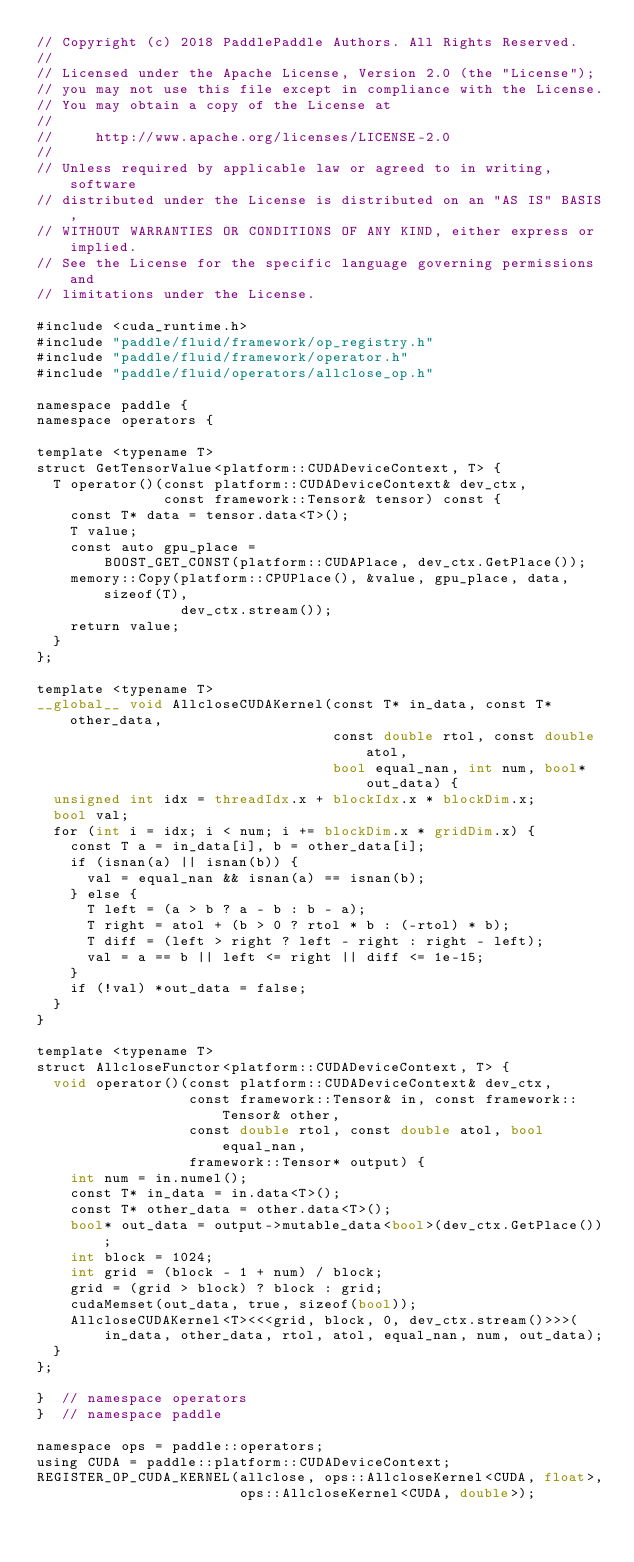Convert code to text. <code><loc_0><loc_0><loc_500><loc_500><_Cuda_>// Copyright (c) 2018 PaddlePaddle Authors. All Rights Reserved.
//
// Licensed under the Apache License, Version 2.0 (the "License");
// you may not use this file except in compliance with the License.
// You may obtain a copy of the License at
//
//     http://www.apache.org/licenses/LICENSE-2.0
//
// Unless required by applicable law or agreed to in writing, software
// distributed under the License is distributed on an "AS IS" BASIS,
// WITHOUT WARRANTIES OR CONDITIONS OF ANY KIND, either express or implied.
// See the License for the specific language governing permissions and
// limitations under the License.

#include <cuda_runtime.h>
#include "paddle/fluid/framework/op_registry.h"
#include "paddle/fluid/framework/operator.h"
#include "paddle/fluid/operators/allclose_op.h"

namespace paddle {
namespace operators {

template <typename T>
struct GetTensorValue<platform::CUDADeviceContext, T> {
  T operator()(const platform::CUDADeviceContext& dev_ctx,
               const framework::Tensor& tensor) const {
    const T* data = tensor.data<T>();
    T value;
    const auto gpu_place =
        BOOST_GET_CONST(platform::CUDAPlace, dev_ctx.GetPlace());
    memory::Copy(platform::CPUPlace(), &value, gpu_place, data, sizeof(T),
                 dev_ctx.stream());
    return value;
  }
};

template <typename T>
__global__ void AllcloseCUDAKernel(const T* in_data, const T* other_data,
                                   const double rtol, const double atol,
                                   bool equal_nan, int num, bool* out_data) {
  unsigned int idx = threadIdx.x + blockIdx.x * blockDim.x;
  bool val;
  for (int i = idx; i < num; i += blockDim.x * gridDim.x) {
    const T a = in_data[i], b = other_data[i];
    if (isnan(a) || isnan(b)) {
      val = equal_nan && isnan(a) == isnan(b);
    } else {
      T left = (a > b ? a - b : b - a);
      T right = atol + (b > 0 ? rtol * b : (-rtol) * b);
      T diff = (left > right ? left - right : right - left);
      val = a == b || left <= right || diff <= 1e-15;
    }
    if (!val) *out_data = false;
  }
}

template <typename T>
struct AllcloseFunctor<platform::CUDADeviceContext, T> {
  void operator()(const platform::CUDADeviceContext& dev_ctx,
                  const framework::Tensor& in, const framework::Tensor& other,
                  const double rtol, const double atol, bool equal_nan,
                  framework::Tensor* output) {
    int num = in.numel();
    const T* in_data = in.data<T>();
    const T* other_data = other.data<T>();
    bool* out_data = output->mutable_data<bool>(dev_ctx.GetPlace());
    int block = 1024;
    int grid = (block - 1 + num) / block;
    grid = (grid > block) ? block : grid;
    cudaMemset(out_data, true, sizeof(bool));
    AllcloseCUDAKernel<T><<<grid, block, 0, dev_ctx.stream()>>>(
        in_data, other_data, rtol, atol, equal_nan, num, out_data);
  }
};

}  // namespace operators
}  // namespace paddle

namespace ops = paddle::operators;
using CUDA = paddle::platform::CUDADeviceContext;
REGISTER_OP_CUDA_KERNEL(allclose, ops::AllcloseKernel<CUDA, float>,
                        ops::AllcloseKernel<CUDA, double>);
</code> 